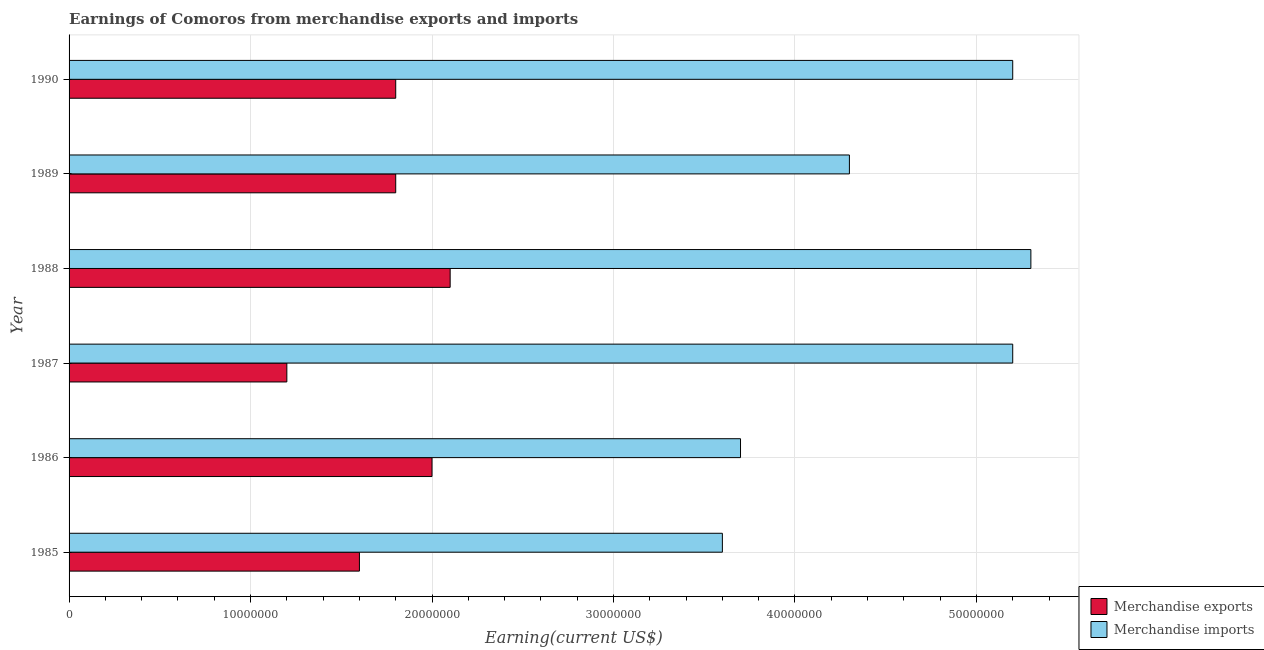How many different coloured bars are there?
Provide a short and direct response. 2. Are the number of bars on each tick of the Y-axis equal?
Your answer should be compact. Yes. How many bars are there on the 3rd tick from the top?
Give a very brief answer. 2. What is the label of the 1st group of bars from the top?
Offer a very short reply. 1990. In how many cases, is the number of bars for a given year not equal to the number of legend labels?
Provide a short and direct response. 0. What is the earnings from merchandise imports in 1985?
Your answer should be very brief. 3.60e+07. Across all years, what is the maximum earnings from merchandise exports?
Offer a very short reply. 2.10e+07. Across all years, what is the minimum earnings from merchandise exports?
Give a very brief answer. 1.20e+07. In which year was the earnings from merchandise exports maximum?
Provide a succinct answer. 1988. What is the total earnings from merchandise imports in the graph?
Make the answer very short. 2.73e+08. What is the difference between the earnings from merchandise imports in 1987 and that in 1990?
Ensure brevity in your answer.  0. What is the difference between the earnings from merchandise exports in 1987 and the earnings from merchandise imports in 1986?
Offer a very short reply. -2.50e+07. What is the average earnings from merchandise exports per year?
Ensure brevity in your answer.  1.75e+07. In the year 1990, what is the difference between the earnings from merchandise imports and earnings from merchandise exports?
Give a very brief answer. 3.40e+07. What is the ratio of the earnings from merchandise imports in 1988 to that in 1990?
Your response must be concise. 1.02. Is the earnings from merchandise exports in 1986 less than that in 1987?
Keep it short and to the point. No. What is the difference between the highest and the second highest earnings from merchandise imports?
Ensure brevity in your answer.  1.00e+06. What is the difference between the highest and the lowest earnings from merchandise exports?
Provide a short and direct response. 9.00e+06. Is the sum of the earnings from merchandise exports in 1989 and 1990 greater than the maximum earnings from merchandise imports across all years?
Offer a very short reply. No. What does the 2nd bar from the top in 1986 represents?
Provide a succinct answer. Merchandise exports. How many bars are there?
Offer a very short reply. 12. Are the values on the major ticks of X-axis written in scientific E-notation?
Keep it short and to the point. No. Does the graph contain any zero values?
Offer a terse response. No. Where does the legend appear in the graph?
Offer a very short reply. Bottom right. How are the legend labels stacked?
Offer a terse response. Vertical. What is the title of the graph?
Offer a terse response. Earnings of Comoros from merchandise exports and imports. Does "Male labor force" appear as one of the legend labels in the graph?
Provide a succinct answer. No. What is the label or title of the X-axis?
Your response must be concise. Earning(current US$). What is the Earning(current US$) of Merchandise exports in 1985?
Give a very brief answer. 1.60e+07. What is the Earning(current US$) of Merchandise imports in 1985?
Keep it short and to the point. 3.60e+07. What is the Earning(current US$) of Merchandise imports in 1986?
Your answer should be compact. 3.70e+07. What is the Earning(current US$) in Merchandise imports in 1987?
Ensure brevity in your answer.  5.20e+07. What is the Earning(current US$) of Merchandise exports in 1988?
Give a very brief answer. 2.10e+07. What is the Earning(current US$) in Merchandise imports in 1988?
Keep it short and to the point. 5.30e+07. What is the Earning(current US$) in Merchandise exports in 1989?
Give a very brief answer. 1.80e+07. What is the Earning(current US$) of Merchandise imports in 1989?
Your response must be concise. 4.30e+07. What is the Earning(current US$) in Merchandise exports in 1990?
Give a very brief answer. 1.80e+07. What is the Earning(current US$) of Merchandise imports in 1990?
Provide a succinct answer. 5.20e+07. Across all years, what is the maximum Earning(current US$) in Merchandise exports?
Your response must be concise. 2.10e+07. Across all years, what is the maximum Earning(current US$) of Merchandise imports?
Provide a short and direct response. 5.30e+07. Across all years, what is the minimum Earning(current US$) in Merchandise exports?
Provide a succinct answer. 1.20e+07. Across all years, what is the minimum Earning(current US$) in Merchandise imports?
Offer a terse response. 3.60e+07. What is the total Earning(current US$) in Merchandise exports in the graph?
Keep it short and to the point. 1.05e+08. What is the total Earning(current US$) in Merchandise imports in the graph?
Make the answer very short. 2.73e+08. What is the difference between the Earning(current US$) in Merchandise imports in 1985 and that in 1986?
Provide a short and direct response. -1.00e+06. What is the difference between the Earning(current US$) of Merchandise exports in 1985 and that in 1987?
Your response must be concise. 4.00e+06. What is the difference between the Earning(current US$) in Merchandise imports in 1985 and that in 1987?
Your answer should be very brief. -1.60e+07. What is the difference between the Earning(current US$) of Merchandise exports in 1985 and that in 1988?
Provide a succinct answer. -5.00e+06. What is the difference between the Earning(current US$) of Merchandise imports in 1985 and that in 1988?
Your response must be concise. -1.70e+07. What is the difference between the Earning(current US$) in Merchandise imports in 1985 and that in 1989?
Your response must be concise. -7.00e+06. What is the difference between the Earning(current US$) in Merchandise imports in 1985 and that in 1990?
Make the answer very short. -1.60e+07. What is the difference between the Earning(current US$) of Merchandise exports in 1986 and that in 1987?
Keep it short and to the point. 8.00e+06. What is the difference between the Earning(current US$) in Merchandise imports in 1986 and that in 1987?
Provide a short and direct response. -1.50e+07. What is the difference between the Earning(current US$) of Merchandise imports in 1986 and that in 1988?
Keep it short and to the point. -1.60e+07. What is the difference between the Earning(current US$) of Merchandise imports in 1986 and that in 1989?
Make the answer very short. -6.00e+06. What is the difference between the Earning(current US$) in Merchandise exports in 1986 and that in 1990?
Your response must be concise. 2.00e+06. What is the difference between the Earning(current US$) of Merchandise imports in 1986 and that in 1990?
Ensure brevity in your answer.  -1.50e+07. What is the difference between the Earning(current US$) of Merchandise exports in 1987 and that in 1988?
Your response must be concise. -9.00e+06. What is the difference between the Earning(current US$) of Merchandise imports in 1987 and that in 1988?
Your answer should be compact. -1.00e+06. What is the difference between the Earning(current US$) of Merchandise exports in 1987 and that in 1989?
Make the answer very short. -6.00e+06. What is the difference between the Earning(current US$) of Merchandise imports in 1987 and that in 1989?
Provide a succinct answer. 9.00e+06. What is the difference between the Earning(current US$) of Merchandise exports in 1987 and that in 1990?
Your response must be concise. -6.00e+06. What is the difference between the Earning(current US$) in Merchandise exports in 1988 and that in 1989?
Your answer should be very brief. 3.00e+06. What is the difference between the Earning(current US$) of Merchandise imports in 1988 and that in 1989?
Your answer should be compact. 1.00e+07. What is the difference between the Earning(current US$) of Merchandise imports in 1988 and that in 1990?
Provide a short and direct response. 1.00e+06. What is the difference between the Earning(current US$) of Merchandise imports in 1989 and that in 1990?
Give a very brief answer. -9.00e+06. What is the difference between the Earning(current US$) of Merchandise exports in 1985 and the Earning(current US$) of Merchandise imports in 1986?
Ensure brevity in your answer.  -2.10e+07. What is the difference between the Earning(current US$) of Merchandise exports in 1985 and the Earning(current US$) of Merchandise imports in 1987?
Your answer should be compact. -3.60e+07. What is the difference between the Earning(current US$) in Merchandise exports in 1985 and the Earning(current US$) in Merchandise imports in 1988?
Keep it short and to the point. -3.70e+07. What is the difference between the Earning(current US$) in Merchandise exports in 1985 and the Earning(current US$) in Merchandise imports in 1989?
Keep it short and to the point. -2.70e+07. What is the difference between the Earning(current US$) in Merchandise exports in 1985 and the Earning(current US$) in Merchandise imports in 1990?
Ensure brevity in your answer.  -3.60e+07. What is the difference between the Earning(current US$) of Merchandise exports in 1986 and the Earning(current US$) of Merchandise imports in 1987?
Your response must be concise. -3.20e+07. What is the difference between the Earning(current US$) in Merchandise exports in 1986 and the Earning(current US$) in Merchandise imports in 1988?
Your answer should be very brief. -3.30e+07. What is the difference between the Earning(current US$) in Merchandise exports in 1986 and the Earning(current US$) in Merchandise imports in 1989?
Give a very brief answer. -2.30e+07. What is the difference between the Earning(current US$) in Merchandise exports in 1986 and the Earning(current US$) in Merchandise imports in 1990?
Provide a succinct answer. -3.20e+07. What is the difference between the Earning(current US$) of Merchandise exports in 1987 and the Earning(current US$) of Merchandise imports in 1988?
Give a very brief answer. -4.10e+07. What is the difference between the Earning(current US$) of Merchandise exports in 1987 and the Earning(current US$) of Merchandise imports in 1989?
Ensure brevity in your answer.  -3.10e+07. What is the difference between the Earning(current US$) in Merchandise exports in 1987 and the Earning(current US$) in Merchandise imports in 1990?
Your answer should be very brief. -4.00e+07. What is the difference between the Earning(current US$) in Merchandise exports in 1988 and the Earning(current US$) in Merchandise imports in 1989?
Your answer should be compact. -2.20e+07. What is the difference between the Earning(current US$) of Merchandise exports in 1988 and the Earning(current US$) of Merchandise imports in 1990?
Provide a succinct answer. -3.10e+07. What is the difference between the Earning(current US$) of Merchandise exports in 1989 and the Earning(current US$) of Merchandise imports in 1990?
Give a very brief answer. -3.40e+07. What is the average Earning(current US$) of Merchandise exports per year?
Keep it short and to the point. 1.75e+07. What is the average Earning(current US$) of Merchandise imports per year?
Give a very brief answer. 4.55e+07. In the year 1985, what is the difference between the Earning(current US$) in Merchandise exports and Earning(current US$) in Merchandise imports?
Keep it short and to the point. -2.00e+07. In the year 1986, what is the difference between the Earning(current US$) in Merchandise exports and Earning(current US$) in Merchandise imports?
Keep it short and to the point. -1.70e+07. In the year 1987, what is the difference between the Earning(current US$) of Merchandise exports and Earning(current US$) of Merchandise imports?
Your answer should be very brief. -4.00e+07. In the year 1988, what is the difference between the Earning(current US$) of Merchandise exports and Earning(current US$) of Merchandise imports?
Your answer should be very brief. -3.20e+07. In the year 1989, what is the difference between the Earning(current US$) in Merchandise exports and Earning(current US$) in Merchandise imports?
Offer a very short reply. -2.50e+07. In the year 1990, what is the difference between the Earning(current US$) in Merchandise exports and Earning(current US$) in Merchandise imports?
Your response must be concise. -3.40e+07. What is the ratio of the Earning(current US$) of Merchandise exports in 1985 to that in 1986?
Offer a very short reply. 0.8. What is the ratio of the Earning(current US$) in Merchandise imports in 1985 to that in 1987?
Offer a very short reply. 0.69. What is the ratio of the Earning(current US$) in Merchandise exports in 1985 to that in 1988?
Make the answer very short. 0.76. What is the ratio of the Earning(current US$) in Merchandise imports in 1985 to that in 1988?
Make the answer very short. 0.68. What is the ratio of the Earning(current US$) in Merchandise imports in 1985 to that in 1989?
Provide a succinct answer. 0.84. What is the ratio of the Earning(current US$) of Merchandise imports in 1985 to that in 1990?
Offer a very short reply. 0.69. What is the ratio of the Earning(current US$) of Merchandise imports in 1986 to that in 1987?
Your response must be concise. 0.71. What is the ratio of the Earning(current US$) in Merchandise imports in 1986 to that in 1988?
Provide a short and direct response. 0.7. What is the ratio of the Earning(current US$) in Merchandise imports in 1986 to that in 1989?
Your answer should be very brief. 0.86. What is the ratio of the Earning(current US$) in Merchandise imports in 1986 to that in 1990?
Give a very brief answer. 0.71. What is the ratio of the Earning(current US$) in Merchandise exports in 1987 to that in 1988?
Offer a terse response. 0.57. What is the ratio of the Earning(current US$) in Merchandise imports in 1987 to that in 1988?
Give a very brief answer. 0.98. What is the ratio of the Earning(current US$) of Merchandise exports in 1987 to that in 1989?
Ensure brevity in your answer.  0.67. What is the ratio of the Earning(current US$) of Merchandise imports in 1987 to that in 1989?
Ensure brevity in your answer.  1.21. What is the ratio of the Earning(current US$) of Merchandise exports in 1987 to that in 1990?
Provide a succinct answer. 0.67. What is the ratio of the Earning(current US$) in Merchandise imports in 1987 to that in 1990?
Give a very brief answer. 1. What is the ratio of the Earning(current US$) of Merchandise exports in 1988 to that in 1989?
Offer a very short reply. 1.17. What is the ratio of the Earning(current US$) in Merchandise imports in 1988 to that in 1989?
Give a very brief answer. 1.23. What is the ratio of the Earning(current US$) in Merchandise exports in 1988 to that in 1990?
Provide a succinct answer. 1.17. What is the ratio of the Earning(current US$) in Merchandise imports in 1988 to that in 1990?
Give a very brief answer. 1.02. What is the ratio of the Earning(current US$) in Merchandise exports in 1989 to that in 1990?
Offer a very short reply. 1. What is the ratio of the Earning(current US$) of Merchandise imports in 1989 to that in 1990?
Provide a succinct answer. 0.83. What is the difference between the highest and the second highest Earning(current US$) in Merchandise exports?
Offer a terse response. 1.00e+06. What is the difference between the highest and the second highest Earning(current US$) of Merchandise imports?
Your response must be concise. 1.00e+06. What is the difference between the highest and the lowest Earning(current US$) in Merchandise exports?
Offer a terse response. 9.00e+06. What is the difference between the highest and the lowest Earning(current US$) of Merchandise imports?
Provide a short and direct response. 1.70e+07. 